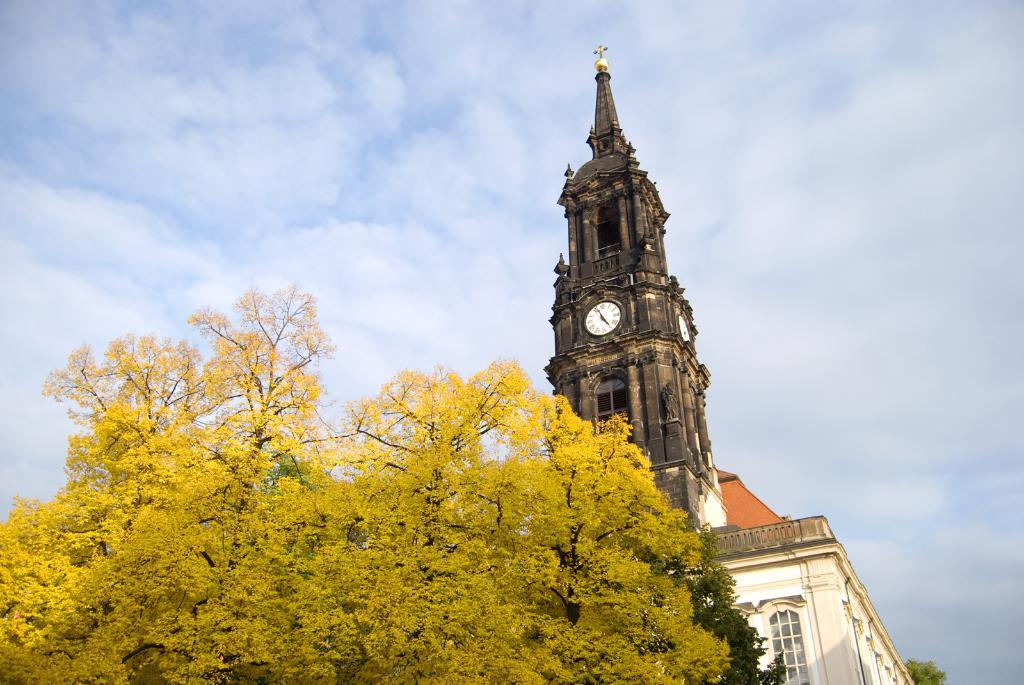What structures are located at the bottom of the image? There is a tree, a clock tower, and a building at the bottom of the image. What can be seen in the sky at the top of the image? The sky is visible at the top of the image, and clouds are present in the sky. Can you tell me how many fingers the boy is holding up in the image? There is no boy present in the image, so it is not possible to determine how many fingers he might be holding up. 